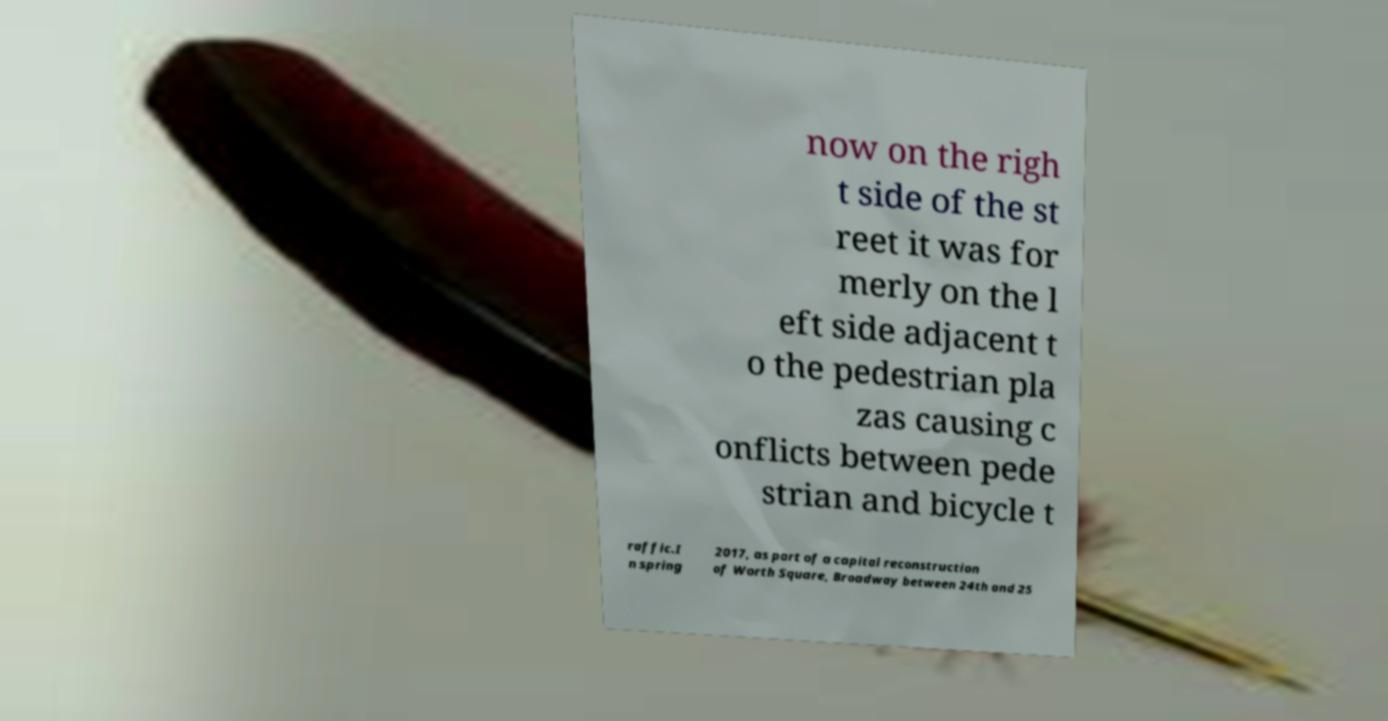What messages or text are displayed in this image? I need them in a readable, typed format. now on the righ t side of the st reet it was for merly on the l eft side adjacent t o the pedestrian pla zas causing c onflicts between pede strian and bicycle t raffic.I n spring 2017, as part of a capital reconstruction of Worth Square, Broadway between 24th and 25 